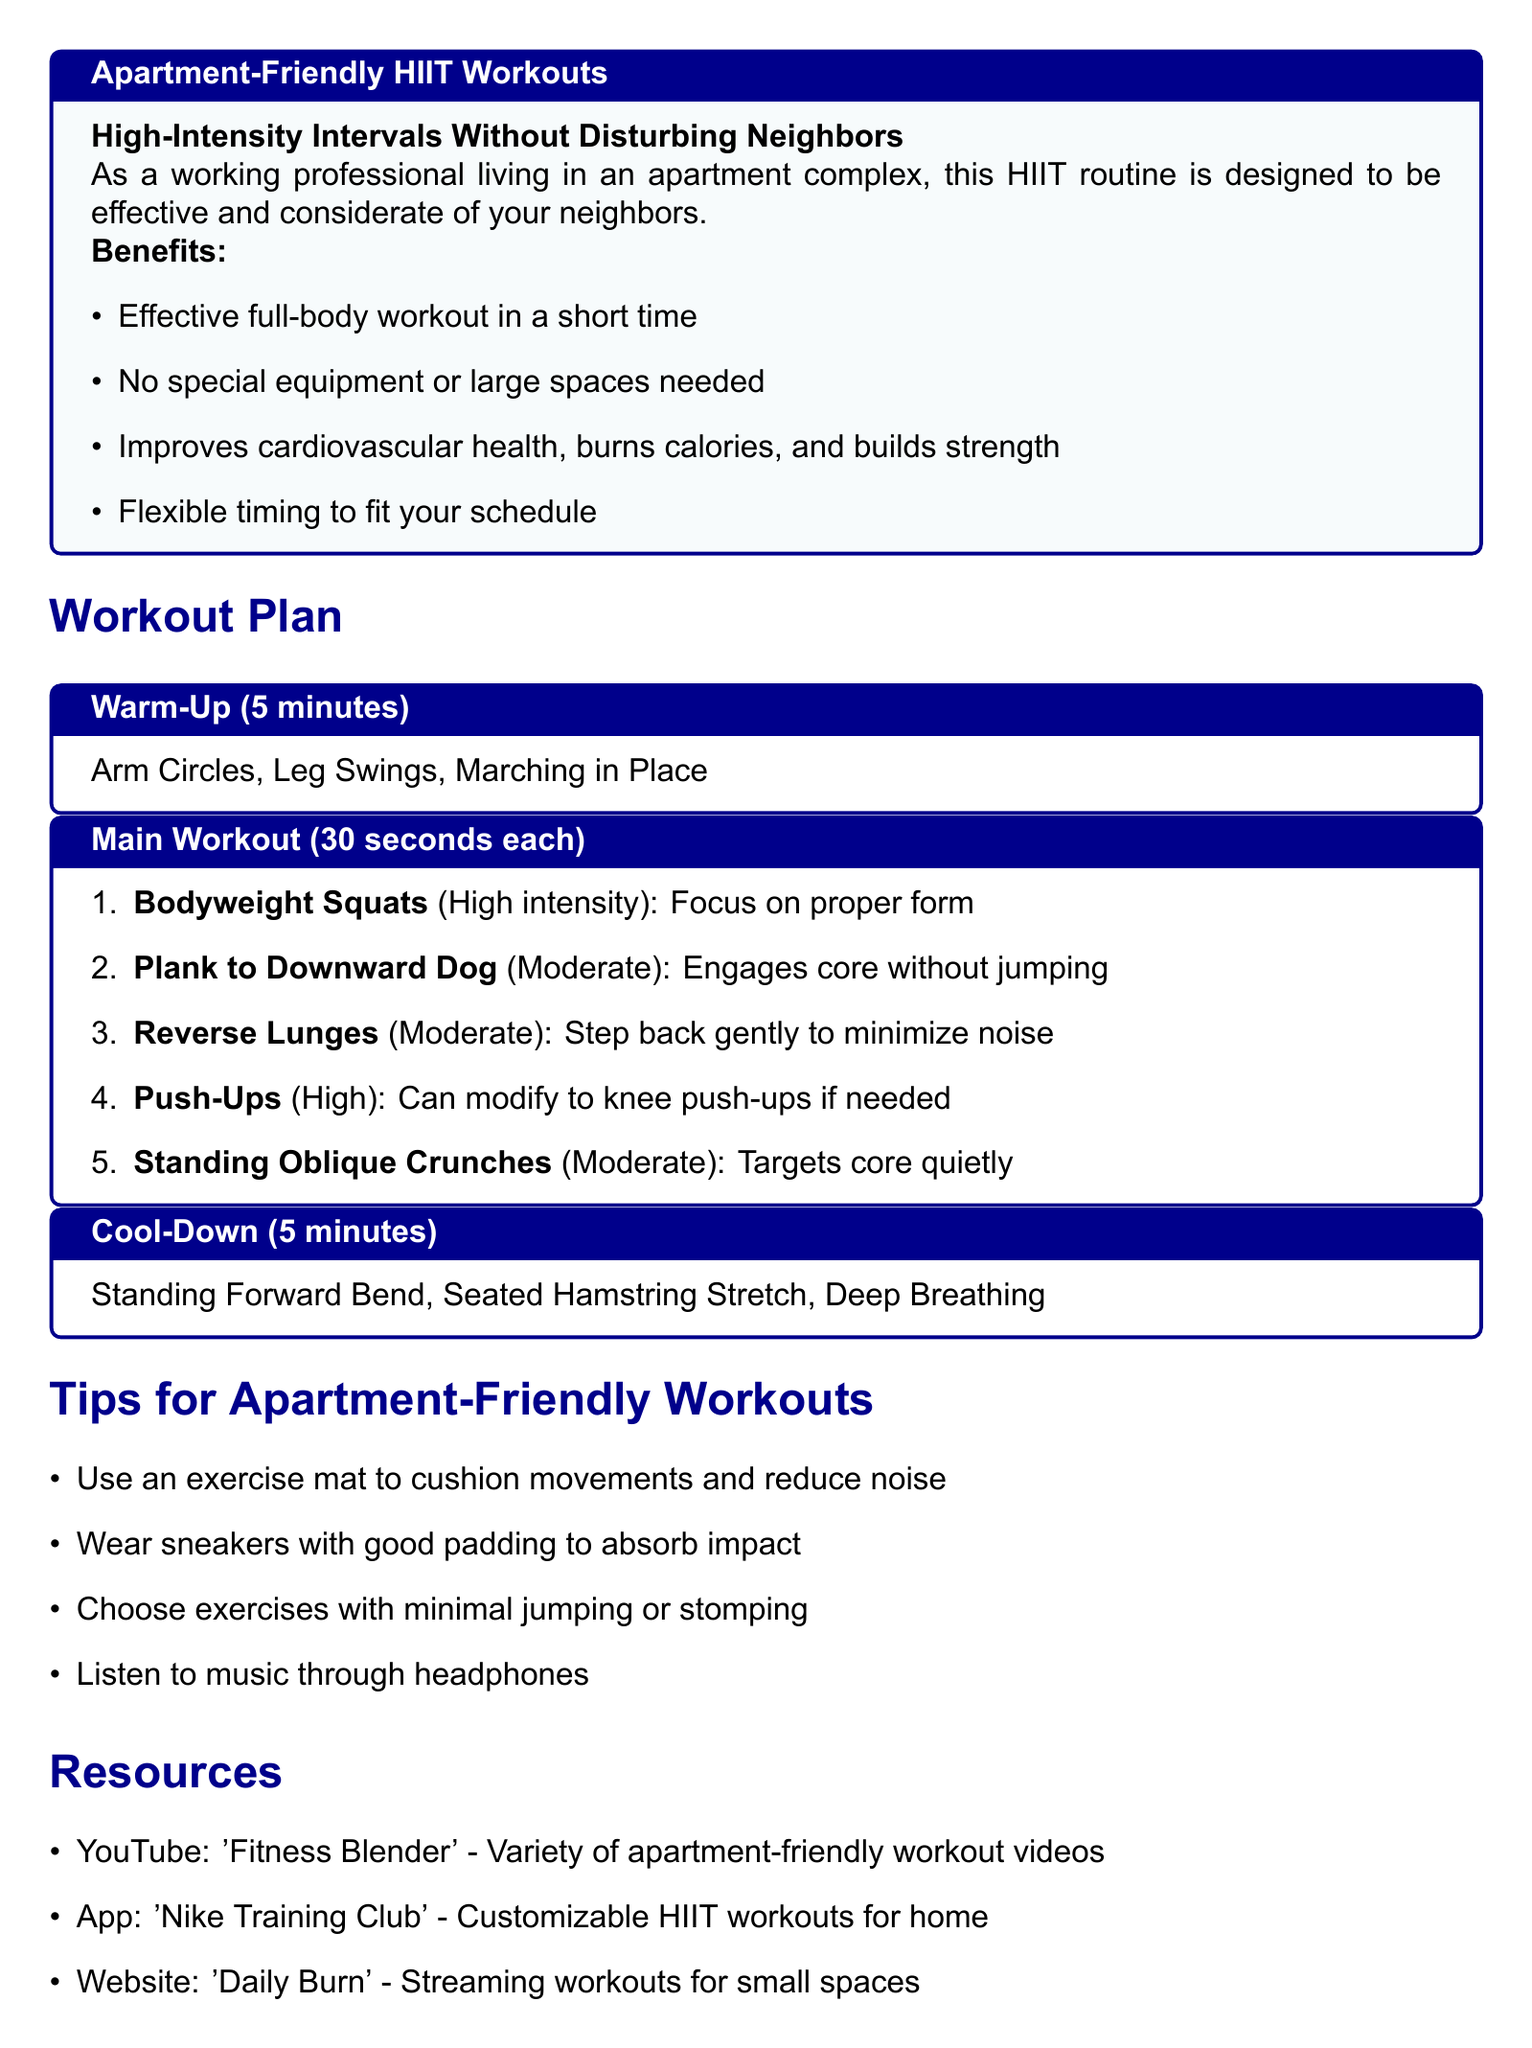What is the duration of the warm-up? The warm-up section specifies a duration of 5 minutes.
Answer: 5 minutes How many exercises are in the main workout? The main workout section lists a total of five exercises.
Answer: 5 exercises What is the first exercise listed in the main workout? The first exercise in the main workout is "Bodyweight Squats."
Answer: Bodyweight Squats What can be used to reduce noise during workouts? The document suggests using an exercise mat to cushion movements and reduce noise.
Answer: Exercise mat Which app is recommended for customizable HIIT workouts? The document recommends the "Nike Training Club" app for customizable HIIT workouts.
Answer: Nike Training Club What is the total duration of the cool-down? The cool-down section specifies a duration of 5 minutes.
Answer: 5 minutes What type of exercises should be minimized for apartment-friendly workouts? The tips suggest minimizing exercises with jumping or stomping.
Answer: Jumping or stomping What is the purpose of the workout plan? The purpose is to provide high-intensity workouts that are considerate of neighbors.
Answer: Effective and considerate workouts 